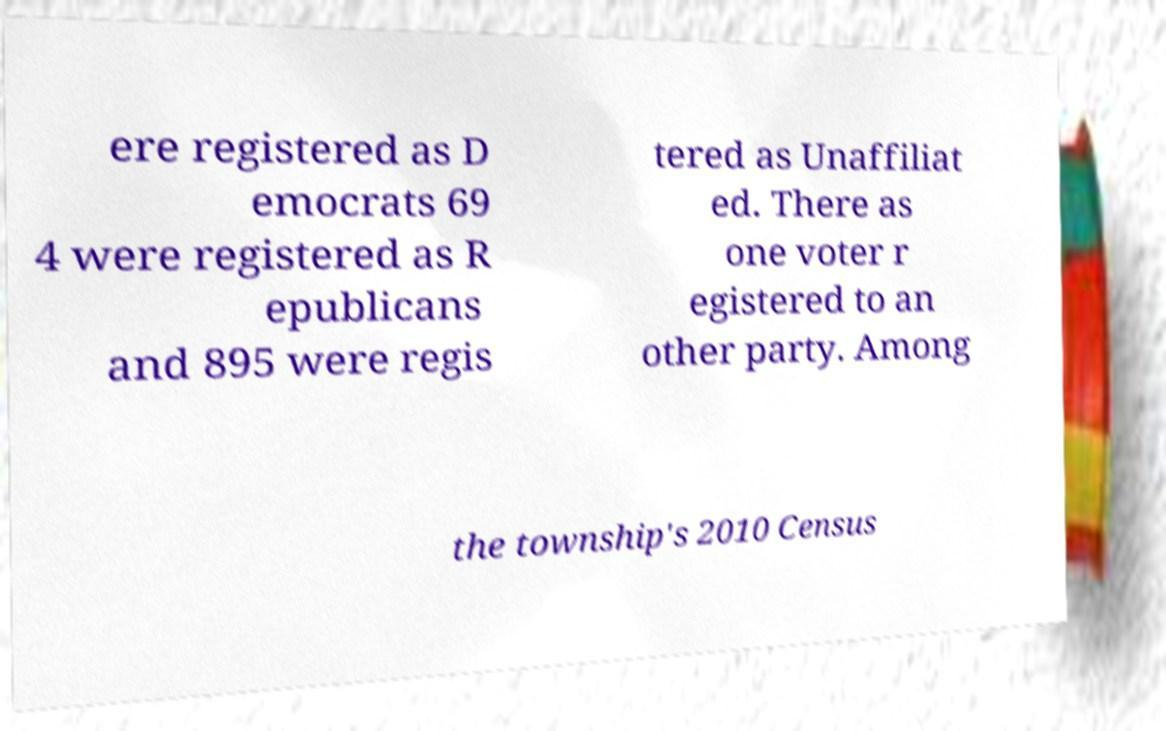Can you accurately transcribe the text from the provided image for me? ere registered as D emocrats 69 4 were registered as R epublicans and 895 were regis tered as Unaffiliat ed. There as one voter r egistered to an other party. Among the township's 2010 Census 